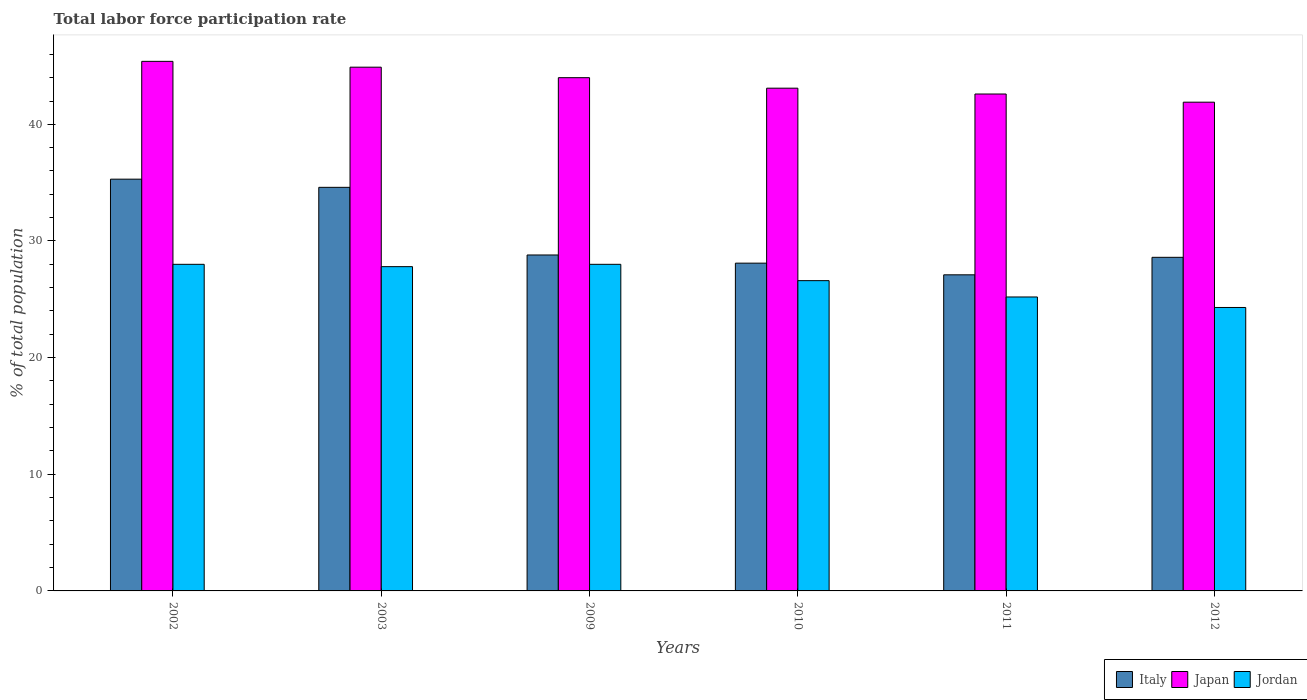How many different coloured bars are there?
Ensure brevity in your answer.  3. How many groups of bars are there?
Provide a succinct answer. 6. How many bars are there on the 4th tick from the left?
Offer a terse response. 3. What is the label of the 6th group of bars from the left?
Offer a very short reply. 2012. In how many cases, is the number of bars for a given year not equal to the number of legend labels?
Your answer should be compact. 0. What is the total labor force participation rate in Italy in 2003?
Your answer should be very brief. 34.6. Across all years, what is the maximum total labor force participation rate in Italy?
Provide a short and direct response. 35.3. Across all years, what is the minimum total labor force participation rate in Italy?
Keep it short and to the point. 27.1. In which year was the total labor force participation rate in Jordan maximum?
Your answer should be very brief. 2002. In which year was the total labor force participation rate in Italy minimum?
Ensure brevity in your answer.  2011. What is the total total labor force participation rate in Jordan in the graph?
Make the answer very short. 159.9. What is the difference between the total labor force participation rate in Italy in 2011 and the total labor force participation rate in Jordan in 2010?
Provide a succinct answer. 0.5. What is the average total labor force participation rate in Jordan per year?
Offer a very short reply. 26.65. Is the total labor force participation rate in Italy in 2002 less than that in 2011?
Your response must be concise. No. Is the difference between the total labor force participation rate in Jordan in 2002 and 2009 greater than the difference between the total labor force participation rate in Japan in 2002 and 2009?
Keep it short and to the point. No. What is the difference between the highest and the second highest total labor force participation rate in Jordan?
Provide a short and direct response. 0. What is the difference between the highest and the lowest total labor force participation rate in Italy?
Offer a terse response. 8.2. Is the sum of the total labor force participation rate in Italy in 2002 and 2009 greater than the maximum total labor force participation rate in Japan across all years?
Your response must be concise. Yes. What does the 3rd bar from the left in 2009 represents?
Offer a very short reply. Jordan. How many bars are there?
Your answer should be very brief. 18. Are all the bars in the graph horizontal?
Make the answer very short. No. What is the difference between two consecutive major ticks on the Y-axis?
Keep it short and to the point. 10. How many legend labels are there?
Provide a succinct answer. 3. What is the title of the graph?
Make the answer very short. Total labor force participation rate. What is the label or title of the X-axis?
Provide a short and direct response. Years. What is the label or title of the Y-axis?
Your response must be concise. % of total population. What is the % of total population of Italy in 2002?
Your answer should be very brief. 35.3. What is the % of total population in Japan in 2002?
Ensure brevity in your answer.  45.4. What is the % of total population of Italy in 2003?
Your answer should be very brief. 34.6. What is the % of total population of Japan in 2003?
Make the answer very short. 44.9. What is the % of total population of Jordan in 2003?
Ensure brevity in your answer.  27.8. What is the % of total population in Italy in 2009?
Your answer should be very brief. 28.8. What is the % of total population in Japan in 2009?
Offer a terse response. 44. What is the % of total population of Italy in 2010?
Ensure brevity in your answer.  28.1. What is the % of total population of Japan in 2010?
Keep it short and to the point. 43.1. What is the % of total population in Jordan in 2010?
Ensure brevity in your answer.  26.6. What is the % of total population in Italy in 2011?
Provide a succinct answer. 27.1. What is the % of total population of Japan in 2011?
Give a very brief answer. 42.6. What is the % of total population in Jordan in 2011?
Provide a short and direct response. 25.2. What is the % of total population of Italy in 2012?
Your response must be concise. 28.6. What is the % of total population in Japan in 2012?
Keep it short and to the point. 41.9. What is the % of total population in Jordan in 2012?
Provide a short and direct response. 24.3. Across all years, what is the maximum % of total population in Italy?
Ensure brevity in your answer.  35.3. Across all years, what is the maximum % of total population of Japan?
Provide a short and direct response. 45.4. Across all years, what is the minimum % of total population in Italy?
Provide a short and direct response. 27.1. Across all years, what is the minimum % of total population in Japan?
Ensure brevity in your answer.  41.9. Across all years, what is the minimum % of total population of Jordan?
Provide a short and direct response. 24.3. What is the total % of total population of Italy in the graph?
Make the answer very short. 182.5. What is the total % of total population of Japan in the graph?
Ensure brevity in your answer.  261.9. What is the total % of total population of Jordan in the graph?
Provide a short and direct response. 159.9. What is the difference between the % of total population of Italy in 2002 and that in 2003?
Your response must be concise. 0.7. What is the difference between the % of total population of Jordan in 2002 and that in 2009?
Your answer should be very brief. 0. What is the difference between the % of total population of Italy in 2002 and that in 2010?
Ensure brevity in your answer.  7.2. What is the difference between the % of total population in Jordan in 2002 and that in 2010?
Provide a short and direct response. 1.4. What is the difference between the % of total population of Japan in 2002 and that in 2012?
Make the answer very short. 3.5. What is the difference between the % of total population of Jordan in 2002 and that in 2012?
Offer a terse response. 3.7. What is the difference between the % of total population in Italy in 2003 and that in 2009?
Keep it short and to the point. 5.8. What is the difference between the % of total population of Japan in 2003 and that in 2009?
Provide a short and direct response. 0.9. What is the difference between the % of total population of Jordan in 2003 and that in 2009?
Your answer should be very brief. -0.2. What is the difference between the % of total population in Italy in 2003 and that in 2010?
Offer a terse response. 6.5. What is the difference between the % of total population in Japan in 2003 and that in 2010?
Your answer should be compact. 1.8. What is the difference between the % of total population in Jordan in 2003 and that in 2010?
Offer a terse response. 1.2. What is the difference between the % of total population of Japan in 2003 and that in 2011?
Ensure brevity in your answer.  2.3. What is the difference between the % of total population of Japan in 2003 and that in 2012?
Your answer should be compact. 3. What is the difference between the % of total population of Jordan in 2003 and that in 2012?
Offer a terse response. 3.5. What is the difference between the % of total population in Italy in 2009 and that in 2010?
Give a very brief answer. 0.7. What is the difference between the % of total population in Jordan in 2009 and that in 2010?
Your answer should be compact. 1.4. What is the difference between the % of total population in Jordan in 2009 and that in 2011?
Provide a succinct answer. 2.8. What is the difference between the % of total population in Italy in 2009 and that in 2012?
Your answer should be compact. 0.2. What is the difference between the % of total population of Japan in 2009 and that in 2012?
Give a very brief answer. 2.1. What is the difference between the % of total population in Jordan in 2009 and that in 2012?
Offer a very short reply. 3.7. What is the difference between the % of total population in Italy in 2010 and that in 2011?
Your response must be concise. 1. What is the difference between the % of total population in Jordan in 2010 and that in 2011?
Your answer should be very brief. 1.4. What is the difference between the % of total population of Italy in 2011 and that in 2012?
Your answer should be very brief. -1.5. What is the difference between the % of total population in Japan in 2011 and that in 2012?
Ensure brevity in your answer.  0.7. What is the difference between the % of total population of Italy in 2002 and the % of total population of Japan in 2003?
Keep it short and to the point. -9.6. What is the difference between the % of total population in Italy in 2002 and the % of total population in Jordan in 2003?
Your response must be concise. 7.5. What is the difference between the % of total population of Italy in 2002 and the % of total population of Japan in 2009?
Provide a succinct answer. -8.7. What is the difference between the % of total population in Italy in 2002 and the % of total population in Japan in 2010?
Keep it short and to the point. -7.8. What is the difference between the % of total population of Italy in 2002 and the % of total population of Jordan in 2010?
Offer a very short reply. 8.7. What is the difference between the % of total population of Italy in 2002 and the % of total population of Japan in 2011?
Offer a terse response. -7.3. What is the difference between the % of total population of Italy in 2002 and the % of total population of Jordan in 2011?
Offer a terse response. 10.1. What is the difference between the % of total population in Japan in 2002 and the % of total population in Jordan in 2011?
Provide a short and direct response. 20.2. What is the difference between the % of total population of Italy in 2002 and the % of total population of Japan in 2012?
Keep it short and to the point. -6.6. What is the difference between the % of total population in Japan in 2002 and the % of total population in Jordan in 2012?
Keep it short and to the point. 21.1. What is the difference between the % of total population in Italy in 2003 and the % of total population in Japan in 2009?
Make the answer very short. -9.4. What is the difference between the % of total population of Italy in 2003 and the % of total population of Jordan in 2009?
Your answer should be very brief. 6.6. What is the difference between the % of total population in Japan in 2003 and the % of total population in Jordan in 2009?
Provide a short and direct response. 16.9. What is the difference between the % of total population in Italy in 2003 and the % of total population in Jordan in 2010?
Offer a very short reply. 8. What is the difference between the % of total population of Japan in 2003 and the % of total population of Jordan in 2010?
Ensure brevity in your answer.  18.3. What is the difference between the % of total population of Italy in 2003 and the % of total population of Japan in 2011?
Provide a succinct answer. -8. What is the difference between the % of total population in Japan in 2003 and the % of total population in Jordan in 2012?
Provide a succinct answer. 20.6. What is the difference between the % of total population in Italy in 2009 and the % of total population in Japan in 2010?
Your answer should be very brief. -14.3. What is the difference between the % of total population in Italy in 2009 and the % of total population in Jordan in 2011?
Offer a very short reply. 3.6. What is the difference between the % of total population of Japan in 2009 and the % of total population of Jordan in 2011?
Your response must be concise. 18.8. What is the difference between the % of total population in Italy in 2009 and the % of total population in Japan in 2012?
Your answer should be very brief. -13.1. What is the difference between the % of total population in Italy in 2009 and the % of total population in Jordan in 2012?
Offer a very short reply. 4.5. What is the difference between the % of total population of Japan in 2009 and the % of total population of Jordan in 2012?
Your response must be concise. 19.7. What is the difference between the % of total population in Italy in 2010 and the % of total population in Jordan in 2011?
Your answer should be compact. 2.9. What is the difference between the % of total population of Japan in 2010 and the % of total population of Jordan in 2011?
Your answer should be compact. 17.9. What is the difference between the % of total population of Italy in 2011 and the % of total population of Japan in 2012?
Your answer should be compact. -14.8. What is the difference between the % of total population of Italy in 2011 and the % of total population of Jordan in 2012?
Offer a terse response. 2.8. What is the difference between the % of total population of Japan in 2011 and the % of total population of Jordan in 2012?
Provide a succinct answer. 18.3. What is the average % of total population in Italy per year?
Make the answer very short. 30.42. What is the average % of total population of Japan per year?
Provide a short and direct response. 43.65. What is the average % of total population in Jordan per year?
Your answer should be very brief. 26.65. In the year 2002, what is the difference between the % of total population of Italy and % of total population of Jordan?
Keep it short and to the point. 7.3. In the year 2002, what is the difference between the % of total population in Japan and % of total population in Jordan?
Your answer should be compact. 17.4. In the year 2003, what is the difference between the % of total population of Japan and % of total population of Jordan?
Your answer should be very brief. 17.1. In the year 2009, what is the difference between the % of total population in Italy and % of total population in Japan?
Your response must be concise. -15.2. In the year 2010, what is the difference between the % of total population of Italy and % of total population of Japan?
Make the answer very short. -15. In the year 2011, what is the difference between the % of total population in Italy and % of total population in Japan?
Offer a terse response. -15.5. In the year 2011, what is the difference between the % of total population of Japan and % of total population of Jordan?
Your answer should be compact. 17.4. In the year 2012, what is the difference between the % of total population in Japan and % of total population in Jordan?
Provide a succinct answer. 17.6. What is the ratio of the % of total population in Italy in 2002 to that in 2003?
Your response must be concise. 1.02. What is the ratio of the % of total population of Japan in 2002 to that in 2003?
Your response must be concise. 1.01. What is the ratio of the % of total population of Italy in 2002 to that in 2009?
Your answer should be very brief. 1.23. What is the ratio of the % of total population in Japan in 2002 to that in 2009?
Keep it short and to the point. 1.03. What is the ratio of the % of total population in Italy in 2002 to that in 2010?
Your answer should be very brief. 1.26. What is the ratio of the % of total population of Japan in 2002 to that in 2010?
Offer a very short reply. 1.05. What is the ratio of the % of total population of Jordan in 2002 to that in 2010?
Keep it short and to the point. 1.05. What is the ratio of the % of total population in Italy in 2002 to that in 2011?
Your answer should be compact. 1.3. What is the ratio of the % of total population of Japan in 2002 to that in 2011?
Provide a succinct answer. 1.07. What is the ratio of the % of total population in Jordan in 2002 to that in 2011?
Offer a very short reply. 1.11. What is the ratio of the % of total population of Italy in 2002 to that in 2012?
Offer a very short reply. 1.23. What is the ratio of the % of total population of Japan in 2002 to that in 2012?
Give a very brief answer. 1.08. What is the ratio of the % of total population in Jordan in 2002 to that in 2012?
Your answer should be compact. 1.15. What is the ratio of the % of total population in Italy in 2003 to that in 2009?
Ensure brevity in your answer.  1.2. What is the ratio of the % of total population in Japan in 2003 to that in 2009?
Your answer should be compact. 1.02. What is the ratio of the % of total population of Jordan in 2003 to that in 2009?
Your answer should be compact. 0.99. What is the ratio of the % of total population in Italy in 2003 to that in 2010?
Offer a very short reply. 1.23. What is the ratio of the % of total population of Japan in 2003 to that in 2010?
Make the answer very short. 1.04. What is the ratio of the % of total population in Jordan in 2003 to that in 2010?
Offer a terse response. 1.05. What is the ratio of the % of total population of Italy in 2003 to that in 2011?
Give a very brief answer. 1.28. What is the ratio of the % of total population in Japan in 2003 to that in 2011?
Your answer should be very brief. 1.05. What is the ratio of the % of total population of Jordan in 2003 to that in 2011?
Your response must be concise. 1.1. What is the ratio of the % of total population of Italy in 2003 to that in 2012?
Provide a short and direct response. 1.21. What is the ratio of the % of total population of Japan in 2003 to that in 2012?
Make the answer very short. 1.07. What is the ratio of the % of total population in Jordan in 2003 to that in 2012?
Provide a short and direct response. 1.14. What is the ratio of the % of total population of Italy in 2009 to that in 2010?
Offer a terse response. 1.02. What is the ratio of the % of total population of Japan in 2009 to that in 2010?
Ensure brevity in your answer.  1.02. What is the ratio of the % of total population of Jordan in 2009 to that in 2010?
Your answer should be compact. 1.05. What is the ratio of the % of total population of Italy in 2009 to that in 2011?
Your answer should be very brief. 1.06. What is the ratio of the % of total population in Japan in 2009 to that in 2011?
Your answer should be very brief. 1.03. What is the ratio of the % of total population in Jordan in 2009 to that in 2011?
Offer a terse response. 1.11. What is the ratio of the % of total population of Japan in 2009 to that in 2012?
Offer a terse response. 1.05. What is the ratio of the % of total population of Jordan in 2009 to that in 2012?
Keep it short and to the point. 1.15. What is the ratio of the % of total population in Italy in 2010 to that in 2011?
Offer a terse response. 1.04. What is the ratio of the % of total population in Japan in 2010 to that in 2011?
Provide a short and direct response. 1.01. What is the ratio of the % of total population of Jordan in 2010 to that in 2011?
Your response must be concise. 1.06. What is the ratio of the % of total population in Italy in 2010 to that in 2012?
Offer a terse response. 0.98. What is the ratio of the % of total population in Japan in 2010 to that in 2012?
Your response must be concise. 1.03. What is the ratio of the % of total population of Jordan in 2010 to that in 2012?
Offer a terse response. 1.09. What is the ratio of the % of total population of Italy in 2011 to that in 2012?
Make the answer very short. 0.95. What is the ratio of the % of total population of Japan in 2011 to that in 2012?
Give a very brief answer. 1.02. What is the ratio of the % of total population in Jordan in 2011 to that in 2012?
Provide a short and direct response. 1.04. What is the difference between the highest and the second highest % of total population in Italy?
Your response must be concise. 0.7. What is the difference between the highest and the second highest % of total population in Japan?
Your answer should be compact. 0.5. What is the difference between the highest and the lowest % of total population of Italy?
Offer a very short reply. 8.2. 